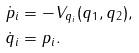Convert formula to latex. <formula><loc_0><loc_0><loc_500><loc_500>\dot { p } _ { i } & = - V _ { q _ { i } } ( q _ { 1 } , q _ { 2 } ) , \\ \dot { q } _ { i } & = p _ { i } .</formula> 